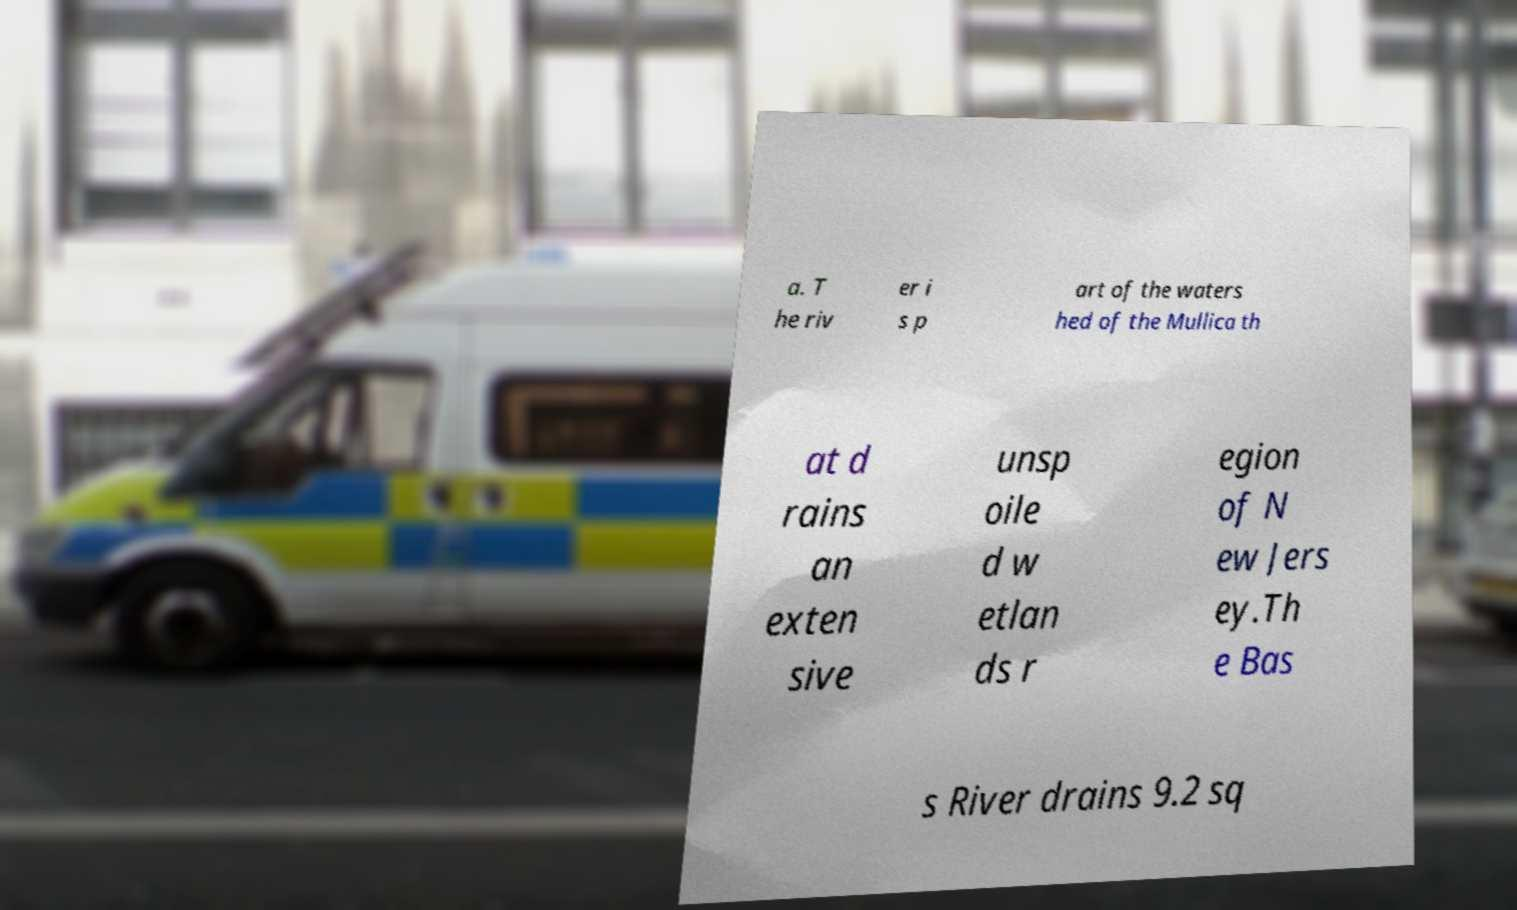Could you extract and type out the text from this image? a. T he riv er i s p art of the waters hed of the Mullica th at d rains an exten sive unsp oile d w etlan ds r egion of N ew Jers ey.Th e Bas s River drains 9.2 sq 